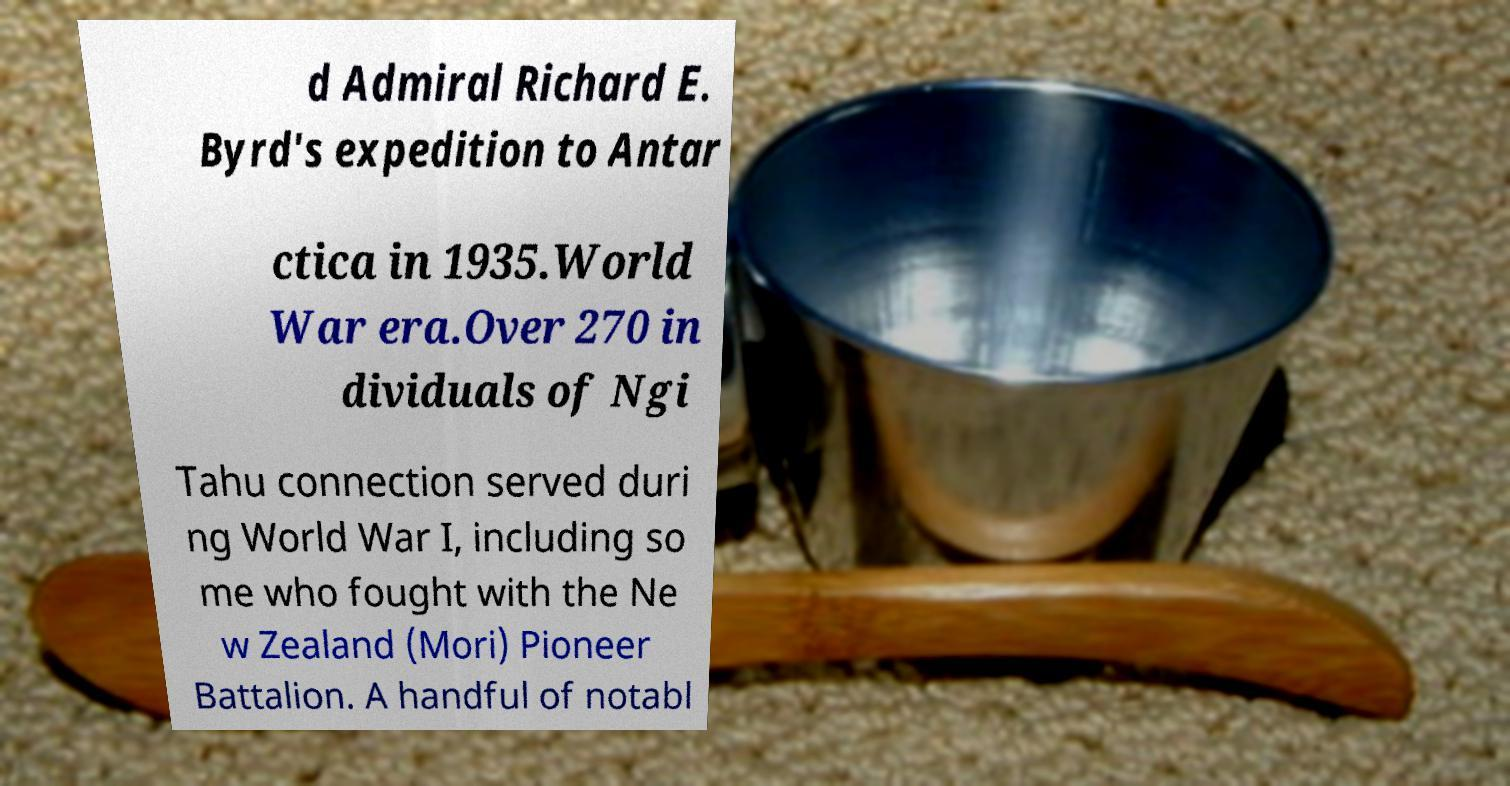Could you extract and type out the text from this image? d Admiral Richard E. Byrd's expedition to Antar ctica in 1935.World War era.Over 270 in dividuals of Ngi Tahu connection served duri ng World War I, including so me who fought with the Ne w Zealand (Mori) Pioneer Battalion. A handful of notabl 